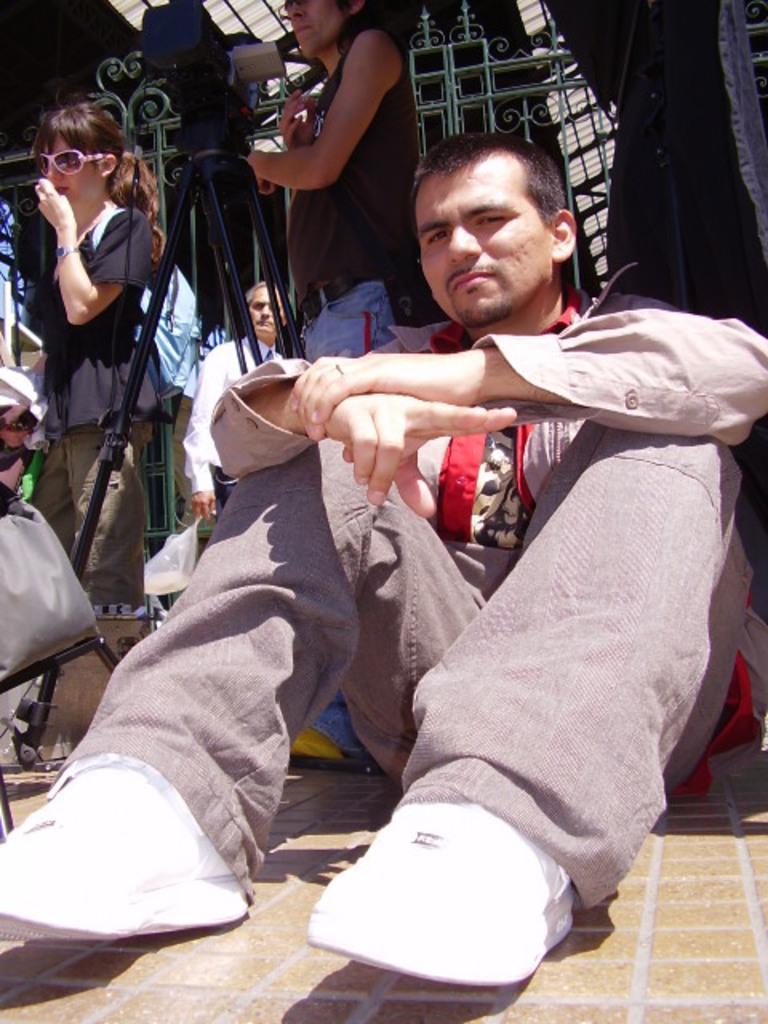In one or two sentences, can you explain what this image depicts? In the middle of the image a man is sitting. Behind him few people are standing and there is a fencing. 